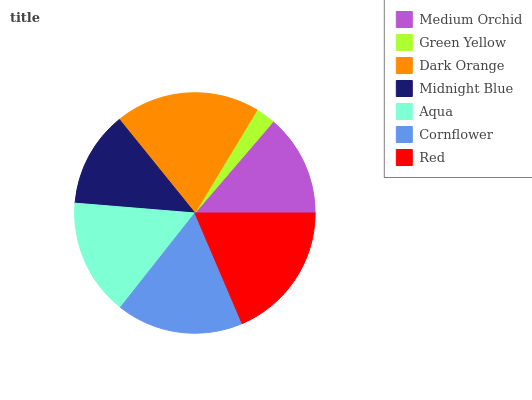Is Green Yellow the minimum?
Answer yes or no. Yes. Is Dark Orange the maximum?
Answer yes or no. Yes. Is Dark Orange the minimum?
Answer yes or no. No. Is Green Yellow the maximum?
Answer yes or no. No. Is Dark Orange greater than Green Yellow?
Answer yes or no. Yes. Is Green Yellow less than Dark Orange?
Answer yes or no. Yes. Is Green Yellow greater than Dark Orange?
Answer yes or no. No. Is Dark Orange less than Green Yellow?
Answer yes or no. No. Is Aqua the high median?
Answer yes or no. Yes. Is Aqua the low median?
Answer yes or no. Yes. Is Red the high median?
Answer yes or no. No. Is Cornflower the low median?
Answer yes or no. No. 